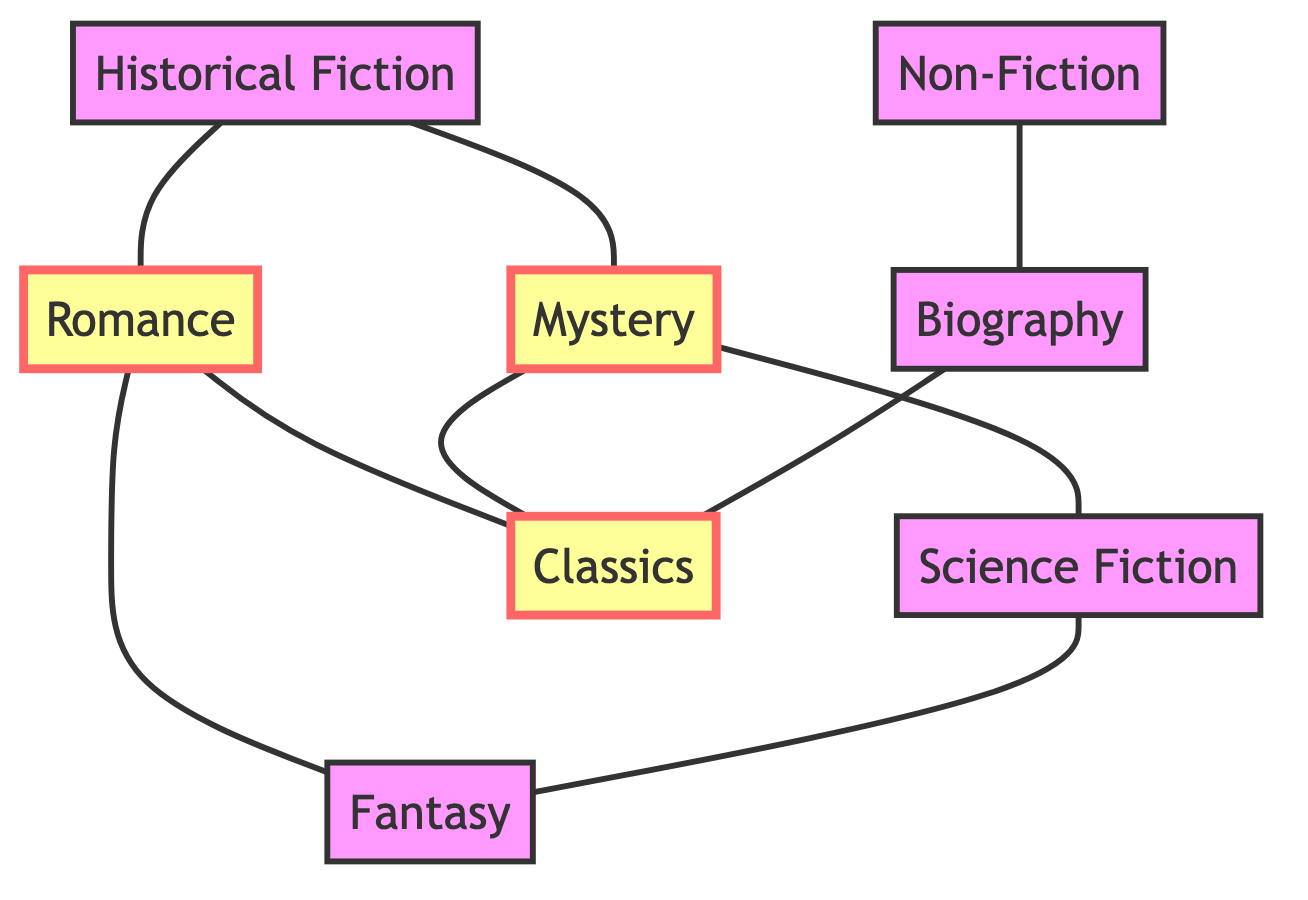What is the total number of nodes in the diagram? The diagram lists eight distinct genres as nodes: Historical Fiction, Romance, Mystery, Science Fiction, Fantasy, Non-Fiction, Biography, and Classics. Therefore, counting each one gives a total of eight nodes.
Answer: 8 Which two genres are directly connected to Historical Fiction? Historical Fiction has two edges connecting it to Romance and Mystery. Each edge represents a direct relationship between the nodes, confirming that these two genres are linked.
Answer: Romance, Mystery How many edges are in the graph? By examining the connections in the diagram, we count the direct relationships drawn between the nodes. There are a total of nine edges, each representing a connection between two genres.
Answer: 9 Which genre shares connections with both Romance and Mystery? When considering the edges connected to both Romance and Mystery, we notice that Classics is directly linked to both genres. Therefore, it is the common genre connected to each.
Answer: Classics What genre is connected to the most other genres? Romance can be seen directly connecting to three other genres: Historical Fiction, Fantasy, and Classics. In contrast, Mystery also connects to three. However, further analysis shows no genre connects to more than three other genres, making Romance and Mystery the most interconnected genres.
Answer: Romance, Mystery Which genres have no direct connections to Non-Fiction? Non-Fiction only has an edge connecting to Biography. By checking the entire graph, we find that it does not connect directly to any of the other genres, specifically excluding Fantasy, Science Fiction, Romance, Mystery, Historical Fiction, and Classics.
Answer: Fantasy, Science Fiction, Romance, Mystery, Historical Fiction, Classics Which two genres form a connection based on a genre crossover? The edge between Romance and Fantasy indicates a crossover between these two genres, showing a connection that may suggest themes or elements they share, such as love stories in fantastical settings.
Answer: Romance, Fantasy What is the common relationship between Biography and Classics? There is a single direct edge connecting Biography to Classics in the diagram, showcasing a relationship where perhaps both genres share historical or narrative-driven elements. This connection helps to indicate thematic similarities or mutual interests.
Answer: Biography 